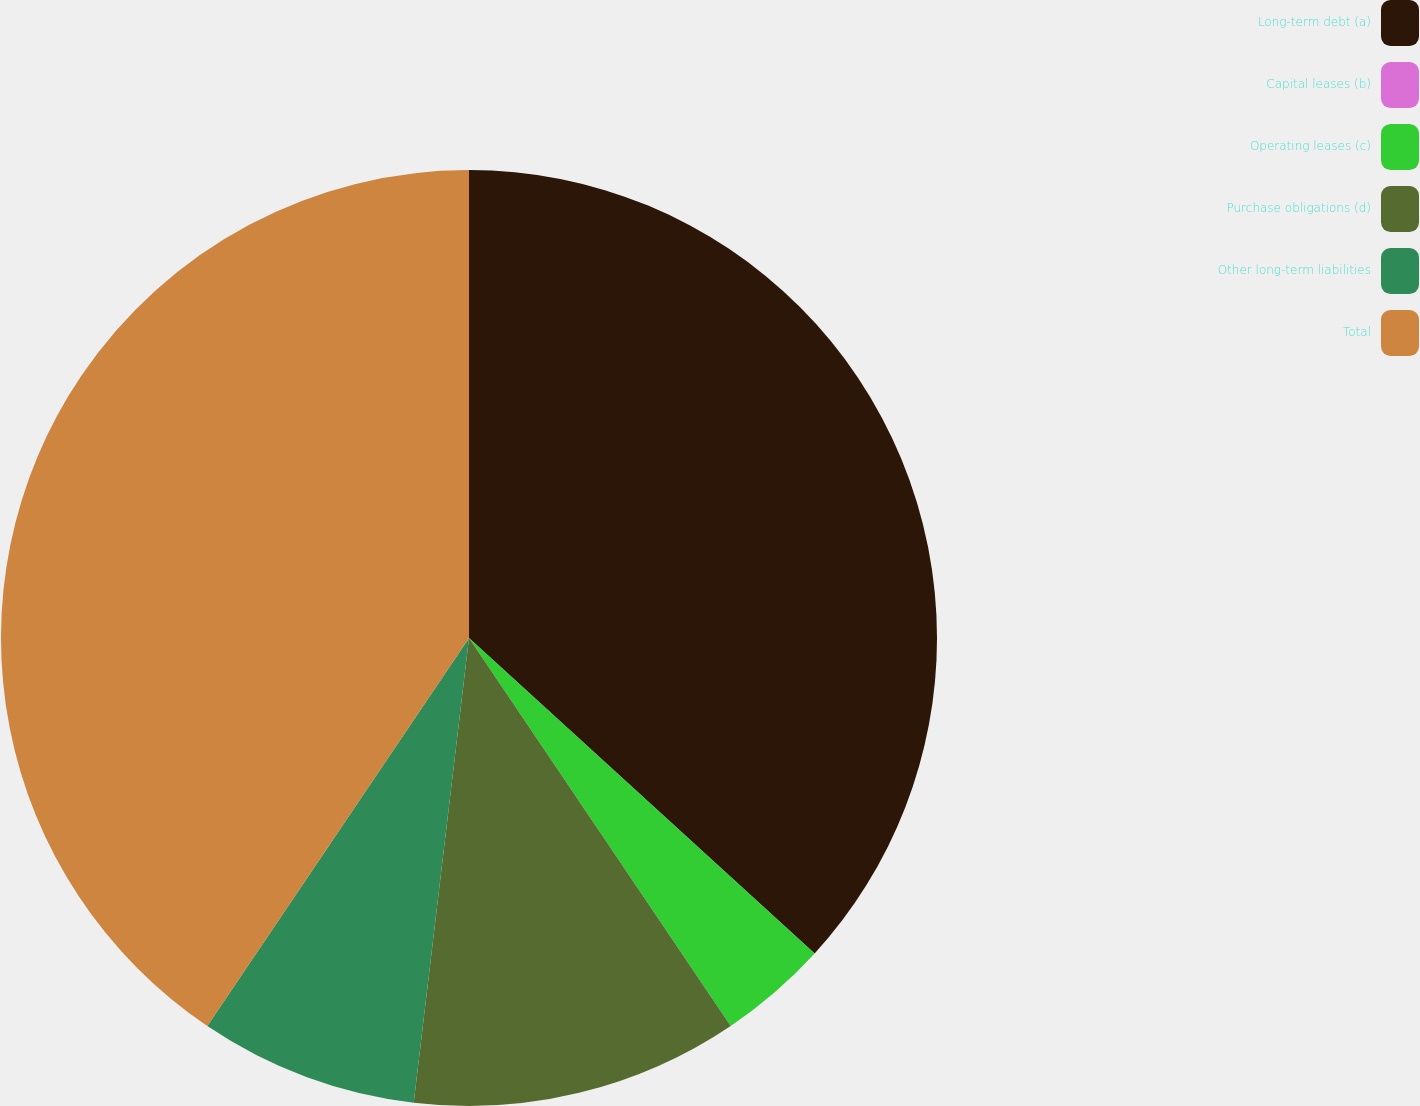<chart> <loc_0><loc_0><loc_500><loc_500><pie_chart><fcel>Long-term debt (a)<fcel>Capital leases (b)<fcel>Operating leases (c)<fcel>Purchase obligations (d)<fcel>Other long-term liabilities<fcel>Total<nl><fcel>36.78%<fcel>0.0%<fcel>3.78%<fcel>11.33%<fcel>7.56%<fcel>40.56%<nl></chart> 